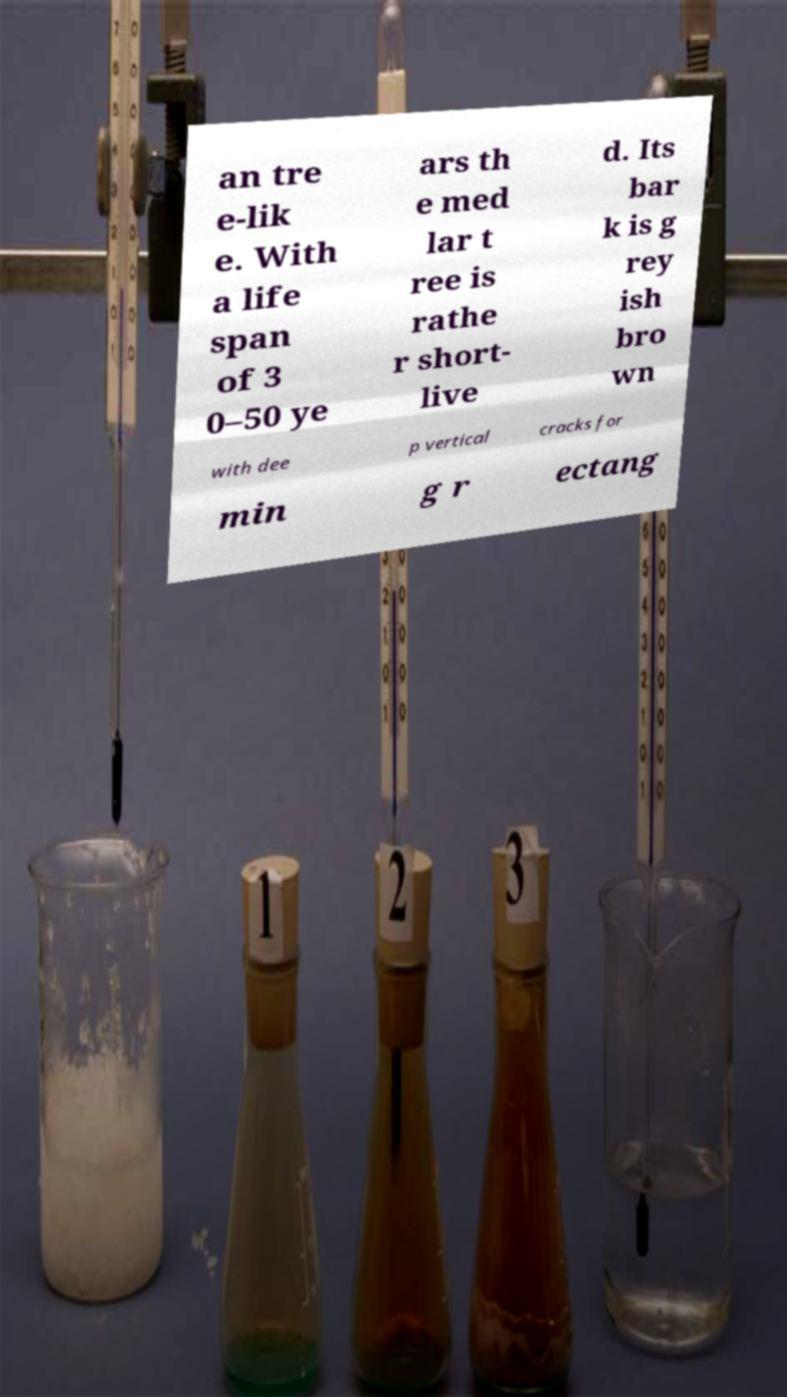Can you read and provide the text displayed in the image?This photo seems to have some interesting text. Can you extract and type it out for me? an tre e-lik e. With a life span of 3 0–50 ye ars th e med lar t ree is rathe r short- live d. Its bar k is g rey ish bro wn with dee p vertical cracks for min g r ectang 